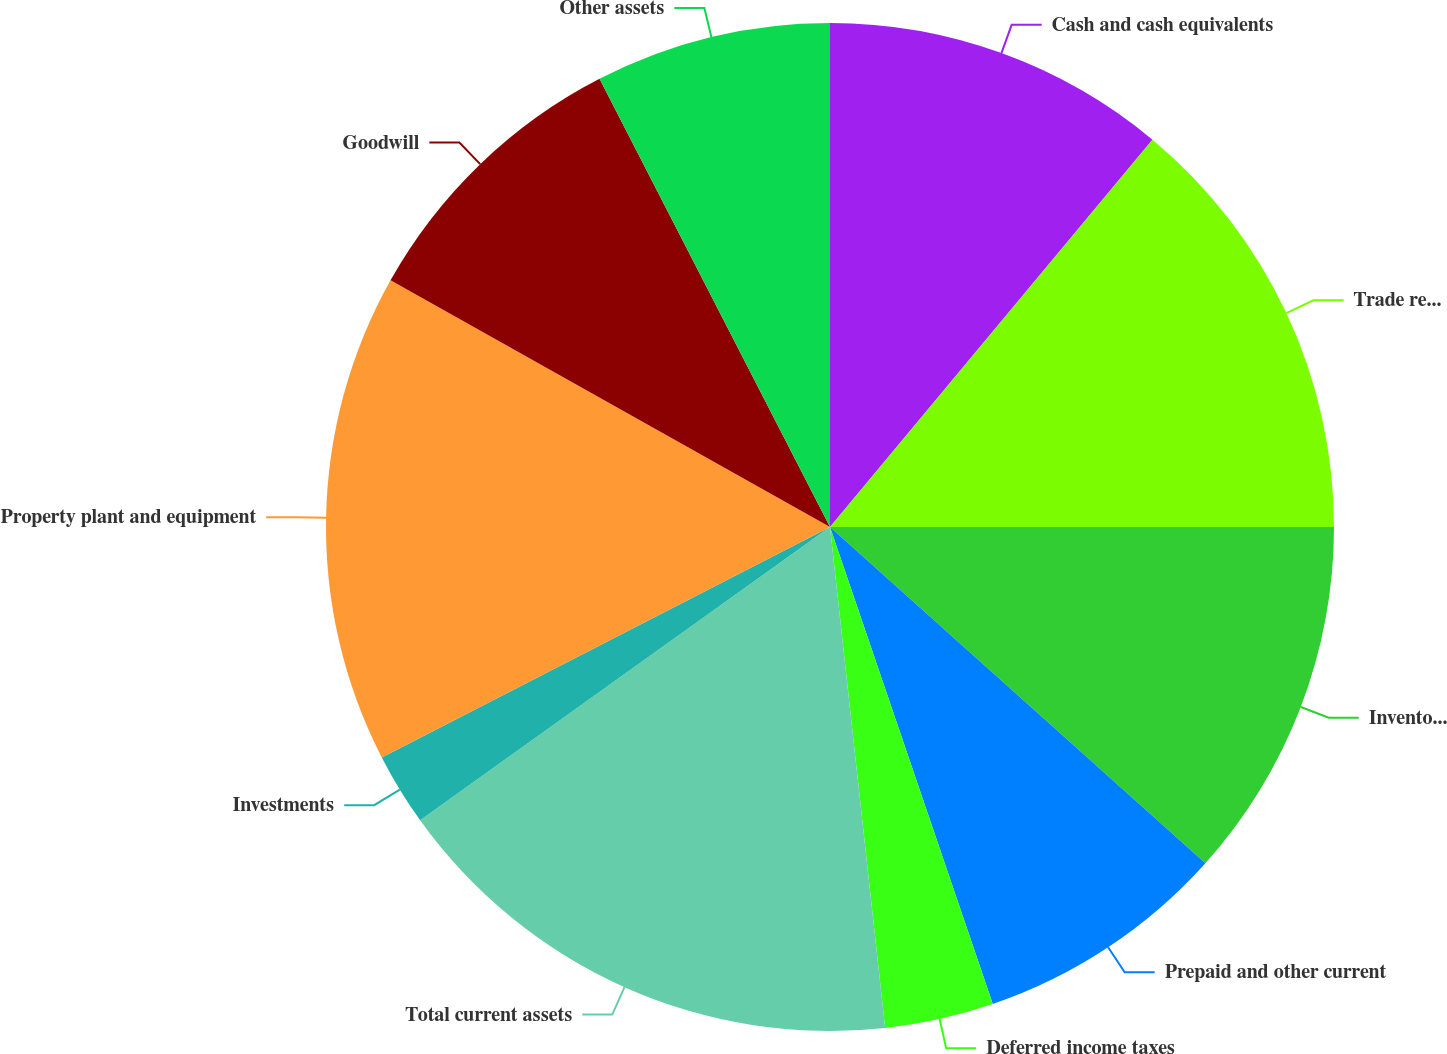Convert chart. <chart><loc_0><loc_0><loc_500><loc_500><pie_chart><fcel>Cash and cash equivalents<fcel>Trade receivables net of<fcel>Inventories<fcel>Prepaid and other current<fcel>Deferred income taxes<fcel>Total current assets<fcel>Investments<fcel>Property plant and equipment<fcel>Goodwill<fcel>Other assets<nl><fcel>11.05%<fcel>13.95%<fcel>11.63%<fcel>8.14%<fcel>3.49%<fcel>16.86%<fcel>2.33%<fcel>15.7%<fcel>9.3%<fcel>7.56%<nl></chart> 